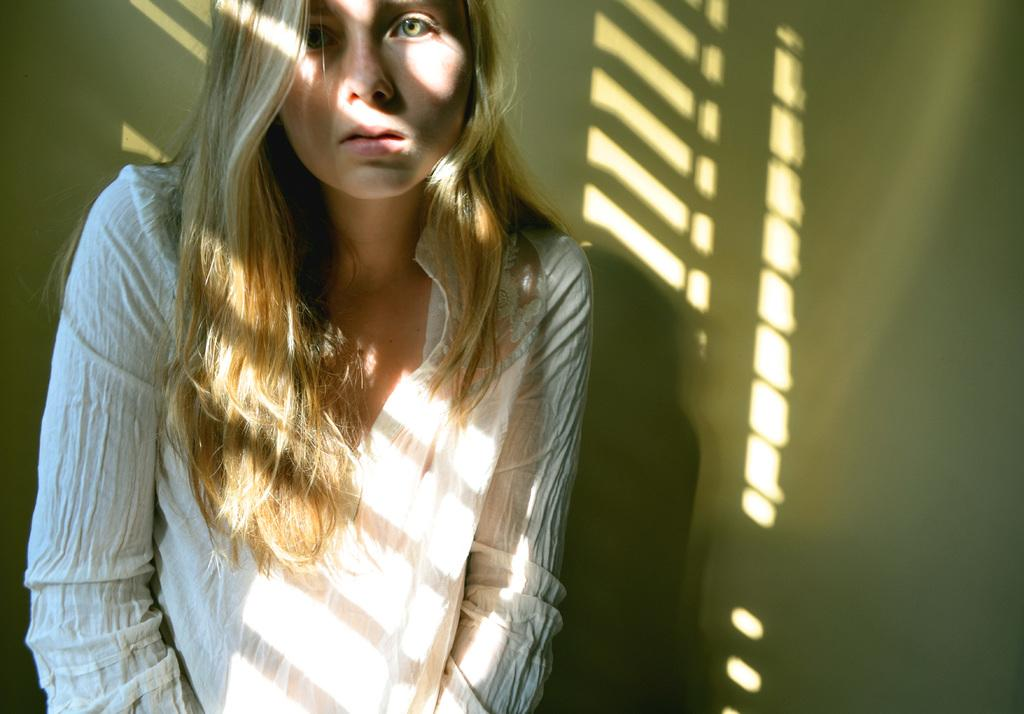Where was the image taken? The image was taken indoors. What can be seen in the background of the image? There is a wall in the background of the image. Who is the main subject in the image? A girl is standing in the middle of the image. Can you describe the girl's appearance? The girl has short hair. What type of engine can be seen in the image? There is no engine present in the image. 